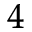Convert formula to latex. <formula><loc_0><loc_0><loc_500><loc_500>^ { 4 }</formula> 